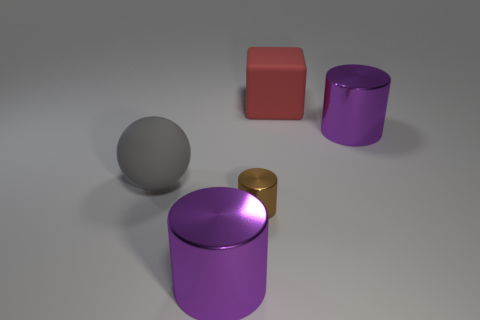Is there anything else that has the same shape as the red rubber object?
Offer a terse response. No. What shape is the purple shiny object that is behind the small cylinder?
Your response must be concise. Cylinder. Is the material of the large cylinder in front of the gray matte ball the same as the purple object that is behind the gray thing?
Give a very brief answer. Yes. What number of large gray things are the same shape as the brown metallic object?
Offer a terse response. 0. What number of objects are small brown cylinders or cylinders to the right of the red matte cube?
Keep it short and to the point. 2. What is the large red cube made of?
Your answer should be compact. Rubber. The large metal cylinder that is behind the purple cylinder that is in front of the big matte sphere is what color?
Provide a short and direct response. Purple. How many rubber things are either purple cylinders or big brown balls?
Your response must be concise. 0. Do the red object and the large gray object have the same material?
Your answer should be compact. Yes. What is the material of the large cylinder left of the purple cylinder that is behind the small brown metallic cylinder?
Your answer should be very brief. Metal. 